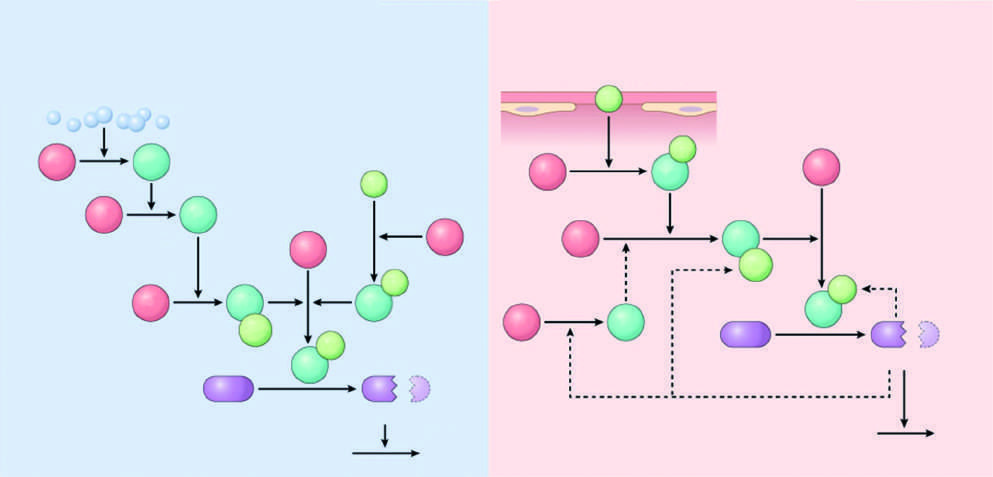re all three transverse sections of myocardium inactive factors?
Answer the question using a single word or phrase. No 